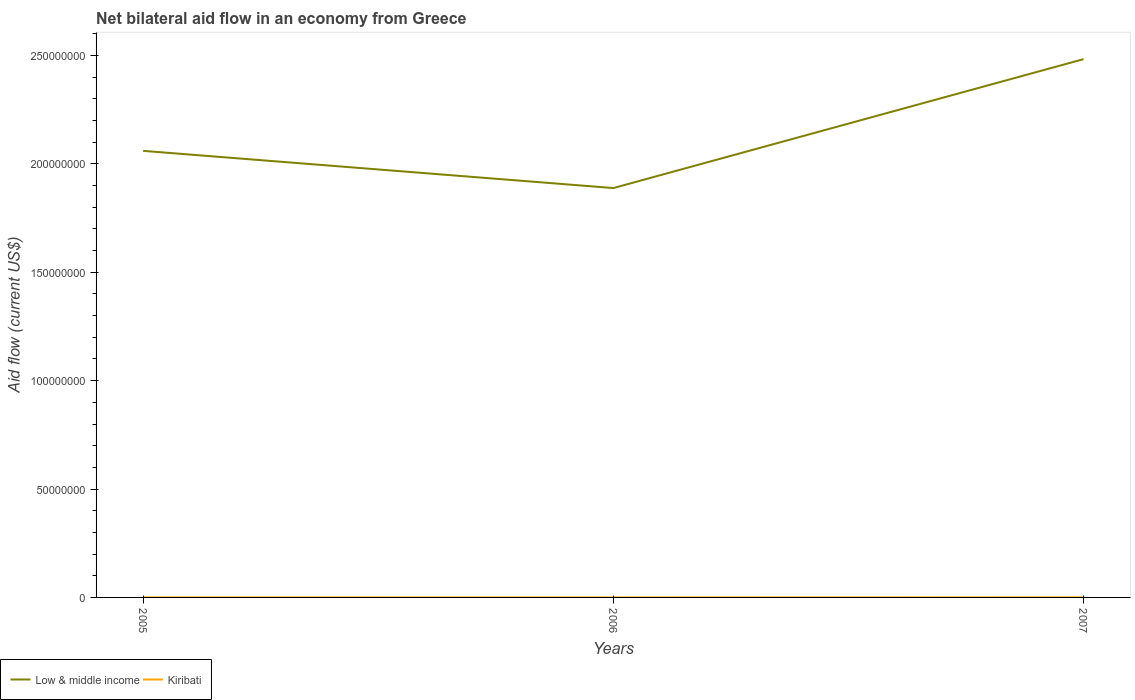How many different coloured lines are there?
Provide a succinct answer. 2. Does the line corresponding to Low & middle income intersect with the line corresponding to Kiribati?
Your response must be concise. No. Across all years, what is the maximum net bilateral aid flow in Low & middle income?
Make the answer very short. 1.89e+08. In which year was the net bilateral aid flow in Kiribati maximum?
Your response must be concise. 2006. What is the total net bilateral aid flow in Low & middle income in the graph?
Make the answer very short. 1.72e+07. What is the difference between the highest and the lowest net bilateral aid flow in Low & middle income?
Give a very brief answer. 1. Does the graph contain any zero values?
Make the answer very short. No. Does the graph contain grids?
Offer a very short reply. No. What is the title of the graph?
Provide a short and direct response. Net bilateral aid flow in an economy from Greece. What is the label or title of the X-axis?
Ensure brevity in your answer.  Years. What is the label or title of the Y-axis?
Keep it short and to the point. Aid flow (current US$). What is the Aid flow (current US$) of Low & middle income in 2005?
Ensure brevity in your answer.  2.06e+08. What is the Aid flow (current US$) of Kiribati in 2005?
Provide a short and direct response. 2.00e+04. What is the Aid flow (current US$) of Low & middle income in 2006?
Provide a short and direct response. 1.89e+08. What is the Aid flow (current US$) of Low & middle income in 2007?
Provide a short and direct response. 2.48e+08. What is the Aid flow (current US$) in Kiribati in 2007?
Your answer should be very brief. 4.00e+04. Across all years, what is the maximum Aid flow (current US$) in Low & middle income?
Offer a very short reply. 2.48e+08. Across all years, what is the maximum Aid flow (current US$) of Kiribati?
Offer a terse response. 4.00e+04. Across all years, what is the minimum Aid flow (current US$) in Low & middle income?
Ensure brevity in your answer.  1.89e+08. Across all years, what is the minimum Aid flow (current US$) of Kiribati?
Your answer should be compact. 10000. What is the total Aid flow (current US$) in Low & middle income in the graph?
Your response must be concise. 6.43e+08. What is the total Aid flow (current US$) in Kiribati in the graph?
Keep it short and to the point. 7.00e+04. What is the difference between the Aid flow (current US$) of Low & middle income in 2005 and that in 2006?
Give a very brief answer. 1.72e+07. What is the difference between the Aid flow (current US$) of Kiribati in 2005 and that in 2006?
Give a very brief answer. 10000. What is the difference between the Aid flow (current US$) of Low & middle income in 2005 and that in 2007?
Your answer should be compact. -4.23e+07. What is the difference between the Aid flow (current US$) of Low & middle income in 2006 and that in 2007?
Keep it short and to the point. -5.95e+07. What is the difference between the Aid flow (current US$) in Kiribati in 2006 and that in 2007?
Your answer should be compact. -3.00e+04. What is the difference between the Aid flow (current US$) of Low & middle income in 2005 and the Aid flow (current US$) of Kiribati in 2006?
Provide a succinct answer. 2.06e+08. What is the difference between the Aid flow (current US$) in Low & middle income in 2005 and the Aid flow (current US$) in Kiribati in 2007?
Make the answer very short. 2.06e+08. What is the difference between the Aid flow (current US$) in Low & middle income in 2006 and the Aid flow (current US$) in Kiribati in 2007?
Your response must be concise. 1.89e+08. What is the average Aid flow (current US$) in Low & middle income per year?
Make the answer very short. 2.14e+08. What is the average Aid flow (current US$) in Kiribati per year?
Provide a succinct answer. 2.33e+04. In the year 2005, what is the difference between the Aid flow (current US$) of Low & middle income and Aid flow (current US$) of Kiribati?
Offer a very short reply. 2.06e+08. In the year 2006, what is the difference between the Aid flow (current US$) in Low & middle income and Aid flow (current US$) in Kiribati?
Provide a succinct answer. 1.89e+08. In the year 2007, what is the difference between the Aid flow (current US$) of Low & middle income and Aid flow (current US$) of Kiribati?
Your answer should be compact. 2.48e+08. What is the ratio of the Aid flow (current US$) in Kiribati in 2005 to that in 2006?
Keep it short and to the point. 2. What is the ratio of the Aid flow (current US$) in Low & middle income in 2005 to that in 2007?
Your answer should be compact. 0.83. What is the ratio of the Aid flow (current US$) of Kiribati in 2005 to that in 2007?
Keep it short and to the point. 0.5. What is the ratio of the Aid flow (current US$) in Low & middle income in 2006 to that in 2007?
Offer a terse response. 0.76. What is the ratio of the Aid flow (current US$) in Kiribati in 2006 to that in 2007?
Make the answer very short. 0.25. What is the difference between the highest and the second highest Aid flow (current US$) in Low & middle income?
Ensure brevity in your answer.  4.23e+07. What is the difference between the highest and the lowest Aid flow (current US$) of Low & middle income?
Provide a succinct answer. 5.95e+07. What is the difference between the highest and the lowest Aid flow (current US$) of Kiribati?
Offer a terse response. 3.00e+04. 